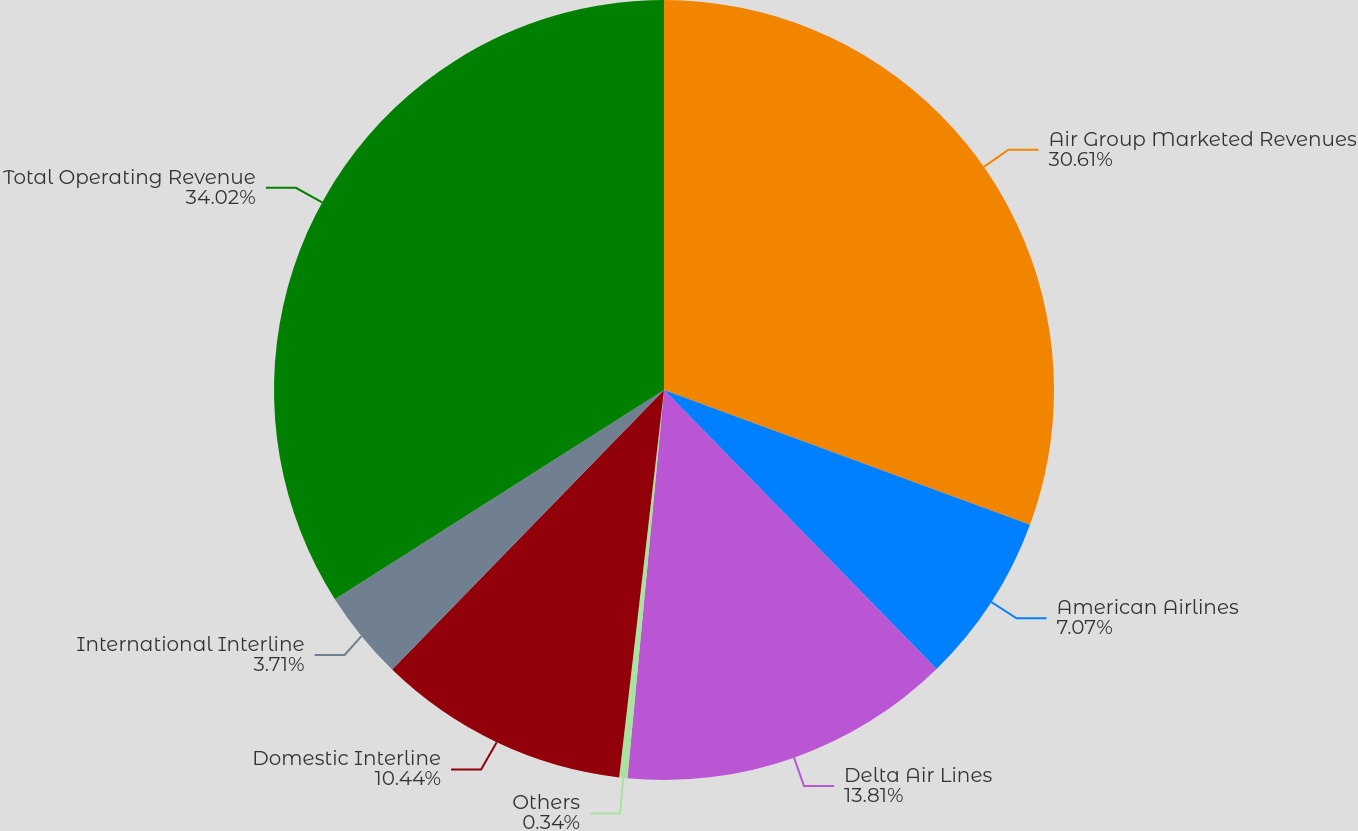<chart> <loc_0><loc_0><loc_500><loc_500><pie_chart><fcel>Air Group Marketed Revenues<fcel>American Airlines<fcel>Delta Air Lines<fcel>Others<fcel>Domestic Interline<fcel>International Interline<fcel>Total Operating Revenue<nl><fcel>30.61%<fcel>7.07%<fcel>13.81%<fcel>0.34%<fcel>10.44%<fcel>3.71%<fcel>34.01%<nl></chart> 